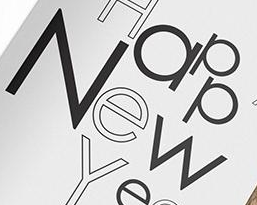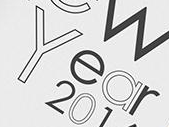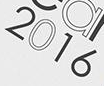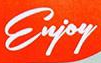Read the text content from these images in order, separated by a semicolon. New; Year; 2016; Enjoy 